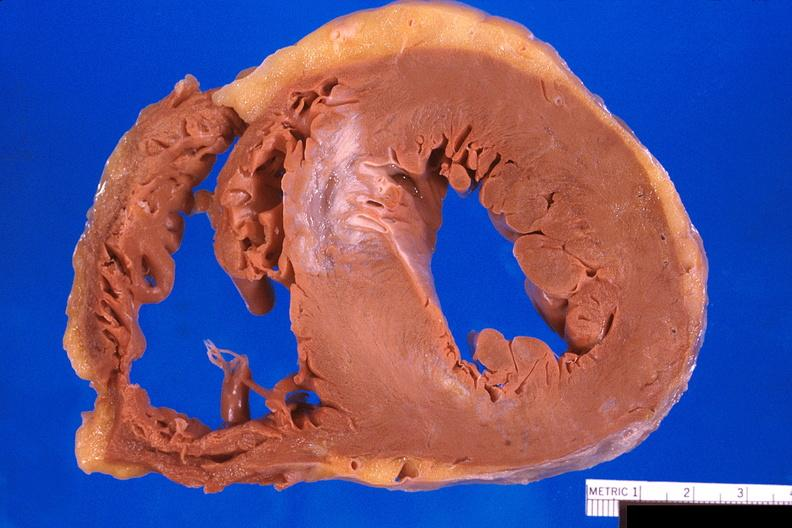s breast present?
Answer the question using a single word or phrase. No 